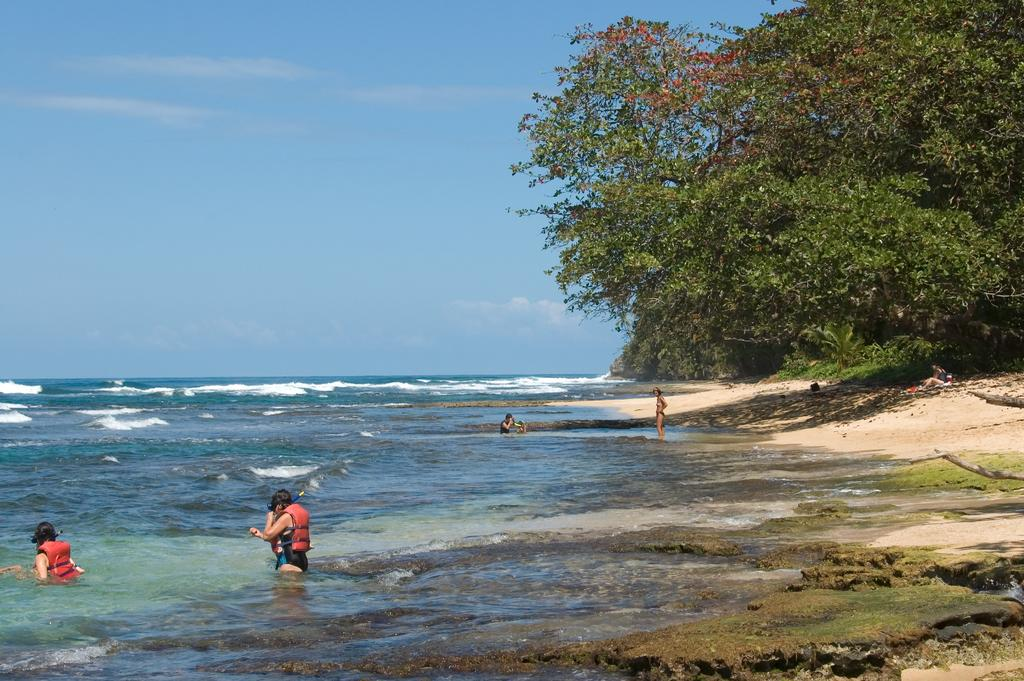What are the people in the image doing? The people in the image are in the water. What can be seen in the right corner of the image? There are trees in the right corner of the image. What type of jewel is the person wearing on their vest in the image? There is no person wearing a vest or any jewel in the image. 